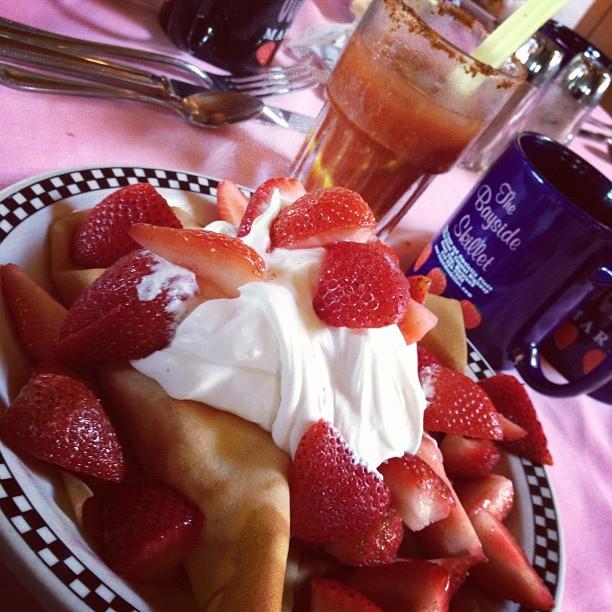What is the name of the restaurant?
Concise answer only. Bayside skillet. Are there utensils on the table?
Give a very brief answer. Yes. Does this appear to be a restaurant setting?
Keep it brief. Yes. 